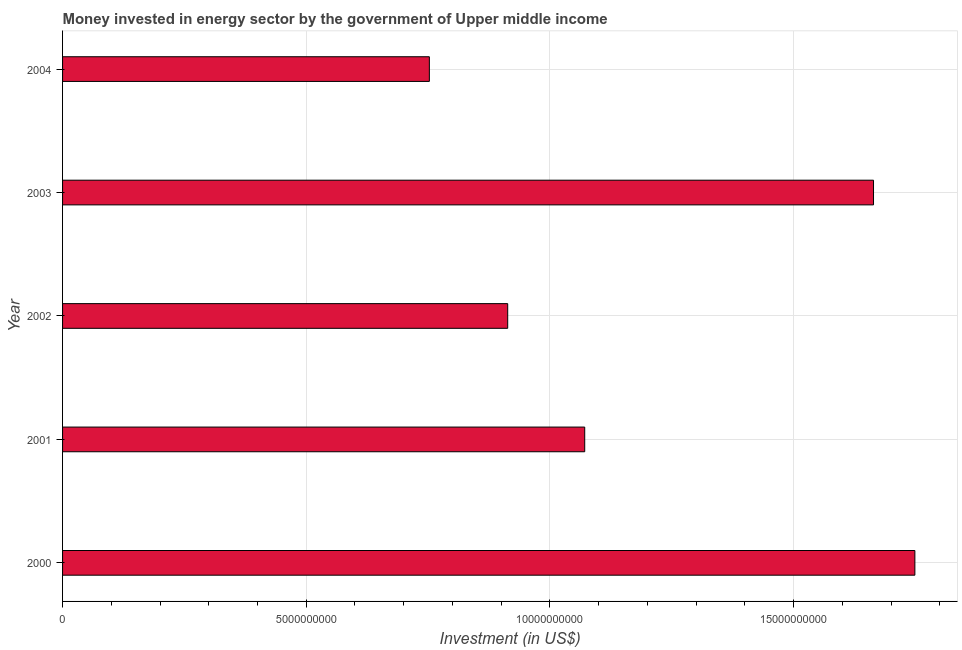Does the graph contain any zero values?
Provide a succinct answer. No. What is the title of the graph?
Your response must be concise. Money invested in energy sector by the government of Upper middle income. What is the label or title of the X-axis?
Your answer should be very brief. Investment (in US$). What is the label or title of the Y-axis?
Ensure brevity in your answer.  Year. What is the investment in energy in 2003?
Keep it short and to the point. 1.66e+1. Across all years, what is the maximum investment in energy?
Your answer should be compact. 1.75e+1. Across all years, what is the minimum investment in energy?
Your answer should be very brief. 7.53e+09. In which year was the investment in energy minimum?
Make the answer very short. 2004. What is the sum of the investment in energy?
Your answer should be very brief. 6.15e+1. What is the difference between the investment in energy in 2002 and 2004?
Your answer should be compact. 1.61e+09. What is the average investment in energy per year?
Offer a terse response. 1.23e+1. What is the median investment in energy?
Your answer should be very brief. 1.07e+1. In how many years, is the investment in energy greater than 9000000000 US$?
Ensure brevity in your answer.  4. Do a majority of the years between 2000 and 2001 (inclusive) have investment in energy greater than 2000000000 US$?
Give a very brief answer. Yes. What is the ratio of the investment in energy in 2001 to that in 2004?
Provide a short and direct response. 1.42. Is the difference between the investment in energy in 2000 and 2002 greater than the difference between any two years?
Your answer should be compact. No. What is the difference between the highest and the second highest investment in energy?
Your response must be concise. 8.49e+08. Is the sum of the investment in energy in 2003 and 2004 greater than the maximum investment in energy across all years?
Your answer should be compact. Yes. What is the difference between the highest and the lowest investment in energy?
Keep it short and to the point. 9.96e+09. In how many years, is the investment in energy greater than the average investment in energy taken over all years?
Make the answer very short. 2. How many years are there in the graph?
Your answer should be compact. 5. What is the difference between two consecutive major ticks on the X-axis?
Your response must be concise. 5.00e+09. What is the Investment (in US$) in 2000?
Ensure brevity in your answer.  1.75e+1. What is the Investment (in US$) in 2001?
Your answer should be very brief. 1.07e+1. What is the Investment (in US$) in 2002?
Your answer should be very brief. 9.13e+09. What is the Investment (in US$) in 2003?
Ensure brevity in your answer.  1.66e+1. What is the Investment (in US$) of 2004?
Your response must be concise. 7.53e+09. What is the difference between the Investment (in US$) in 2000 and 2001?
Your answer should be very brief. 6.77e+09. What is the difference between the Investment (in US$) in 2000 and 2002?
Offer a very short reply. 8.35e+09. What is the difference between the Investment (in US$) in 2000 and 2003?
Provide a short and direct response. 8.49e+08. What is the difference between the Investment (in US$) in 2000 and 2004?
Keep it short and to the point. 9.96e+09. What is the difference between the Investment (in US$) in 2001 and 2002?
Your answer should be compact. 1.58e+09. What is the difference between the Investment (in US$) in 2001 and 2003?
Your answer should be very brief. -5.93e+09. What is the difference between the Investment (in US$) in 2001 and 2004?
Your answer should be very brief. 3.19e+09. What is the difference between the Investment (in US$) in 2002 and 2003?
Make the answer very short. -7.51e+09. What is the difference between the Investment (in US$) in 2002 and 2004?
Ensure brevity in your answer.  1.61e+09. What is the difference between the Investment (in US$) in 2003 and 2004?
Your answer should be compact. 9.11e+09. What is the ratio of the Investment (in US$) in 2000 to that in 2001?
Keep it short and to the point. 1.63. What is the ratio of the Investment (in US$) in 2000 to that in 2002?
Provide a short and direct response. 1.92. What is the ratio of the Investment (in US$) in 2000 to that in 2003?
Your response must be concise. 1.05. What is the ratio of the Investment (in US$) in 2000 to that in 2004?
Your response must be concise. 2.32. What is the ratio of the Investment (in US$) in 2001 to that in 2002?
Make the answer very short. 1.17. What is the ratio of the Investment (in US$) in 2001 to that in 2003?
Your answer should be compact. 0.64. What is the ratio of the Investment (in US$) in 2001 to that in 2004?
Keep it short and to the point. 1.42. What is the ratio of the Investment (in US$) in 2002 to that in 2003?
Make the answer very short. 0.55. What is the ratio of the Investment (in US$) in 2002 to that in 2004?
Give a very brief answer. 1.21. What is the ratio of the Investment (in US$) in 2003 to that in 2004?
Provide a succinct answer. 2.21. 